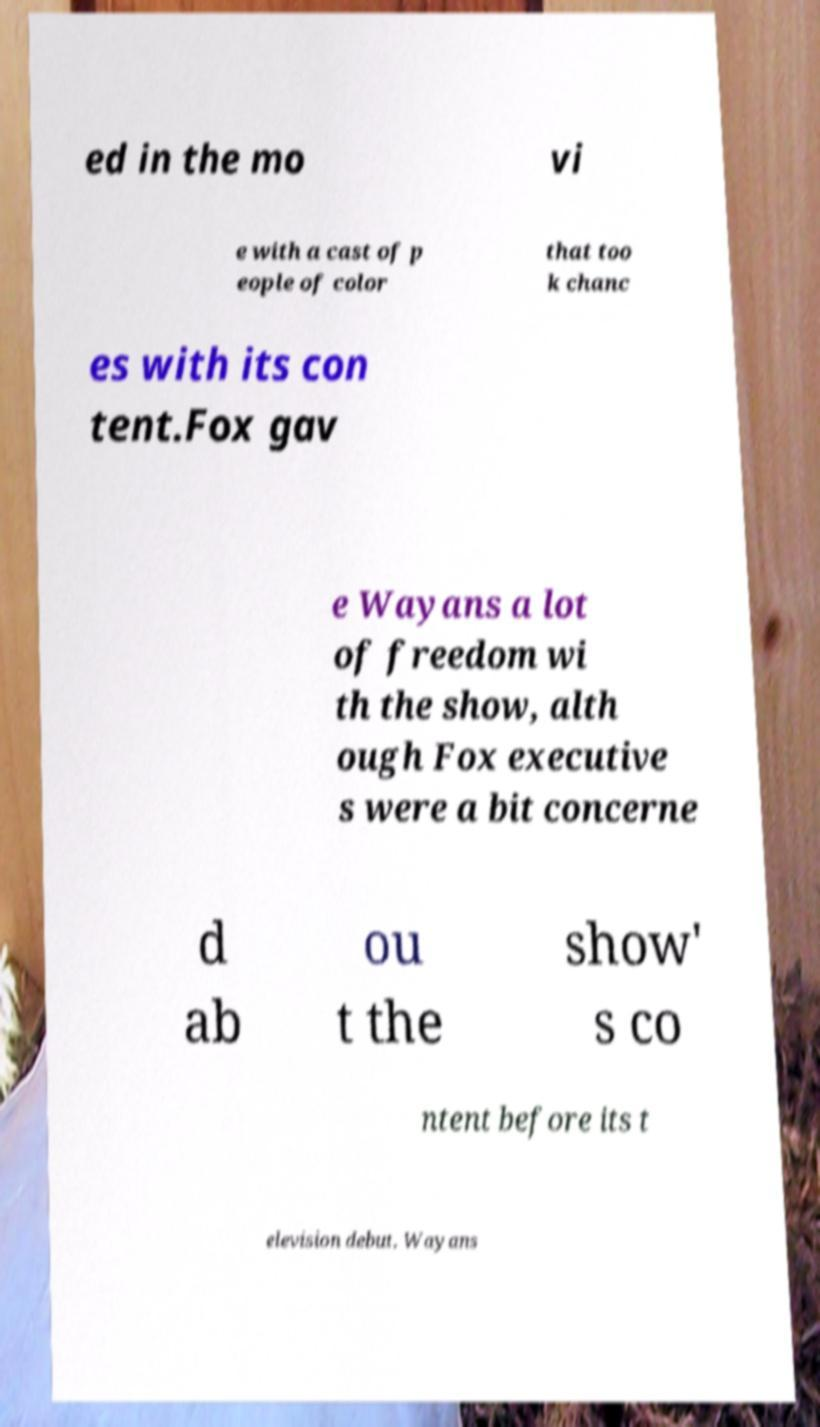Please read and relay the text visible in this image. What does it say? ed in the mo vi e with a cast of p eople of color that too k chanc es with its con tent.Fox gav e Wayans a lot of freedom wi th the show, alth ough Fox executive s were a bit concerne d ab ou t the show' s co ntent before its t elevision debut. Wayans 